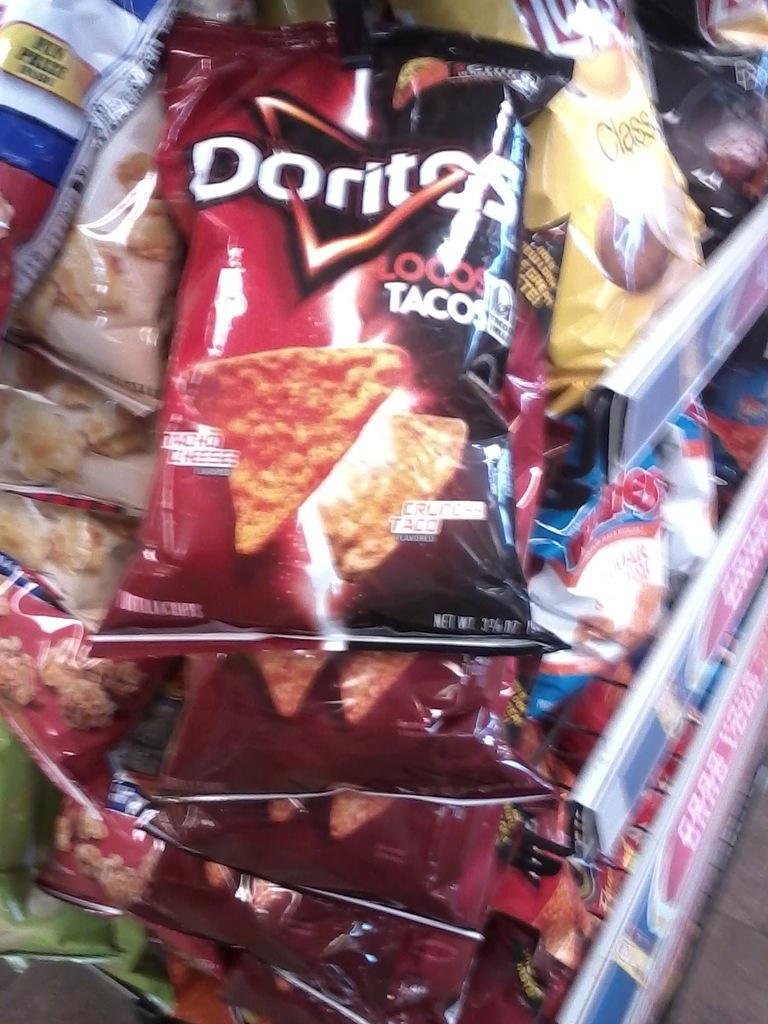<image>
Relay a brief, clear account of the picture shown. a bag of chips that has the word Doritos on it 